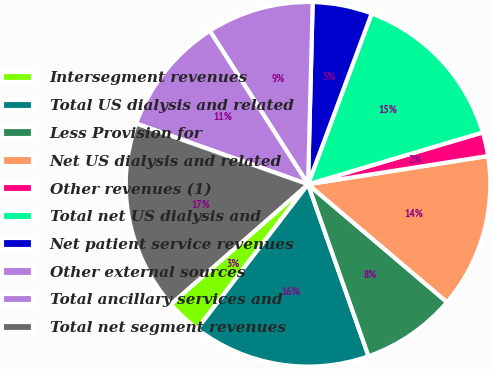<chart> <loc_0><loc_0><loc_500><loc_500><pie_chart><fcel>Intersegment revenues<fcel>Total US dialysis and related<fcel>Less Provision for<fcel>Net US dialysis and related<fcel>Other revenues (1)<fcel>Total net US dialysis and<fcel>Net patient service revenues<fcel>Other external sources<fcel>Total ancillary services and<fcel>Total net segment revenues<nl><fcel>3.16%<fcel>15.79%<fcel>8.42%<fcel>13.68%<fcel>2.11%<fcel>14.73%<fcel>5.27%<fcel>9.47%<fcel>10.53%<fcel>16.84%<nl></chart> 